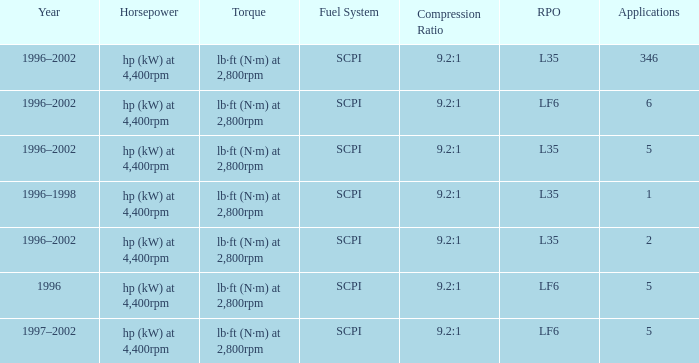What are the torque characteristics of the model made in 1996? Lb·ft (n·m) at 2,800rpm. 